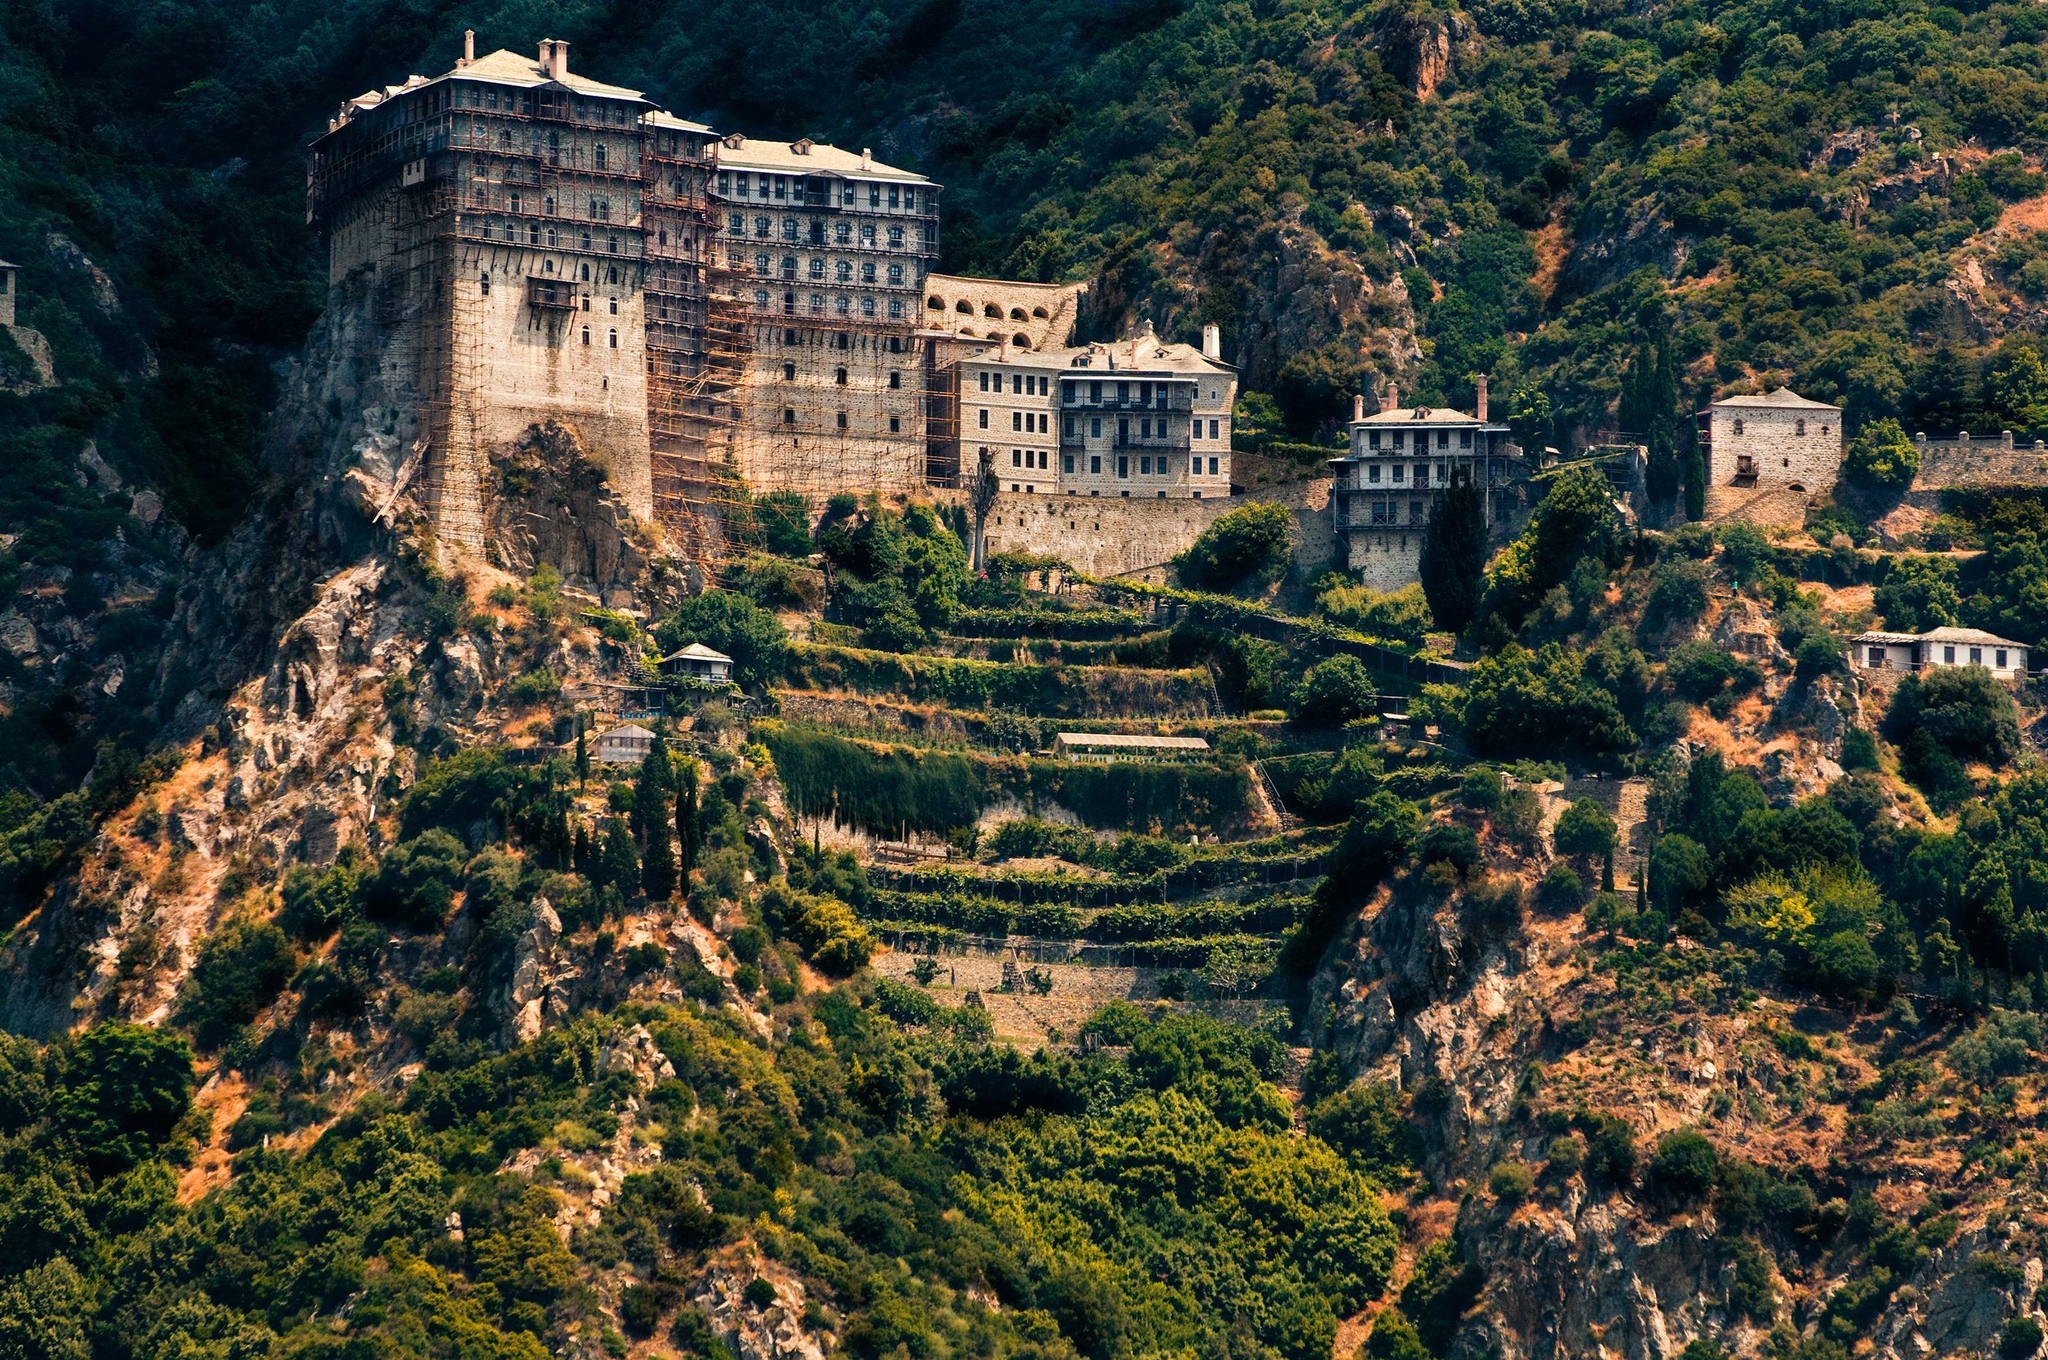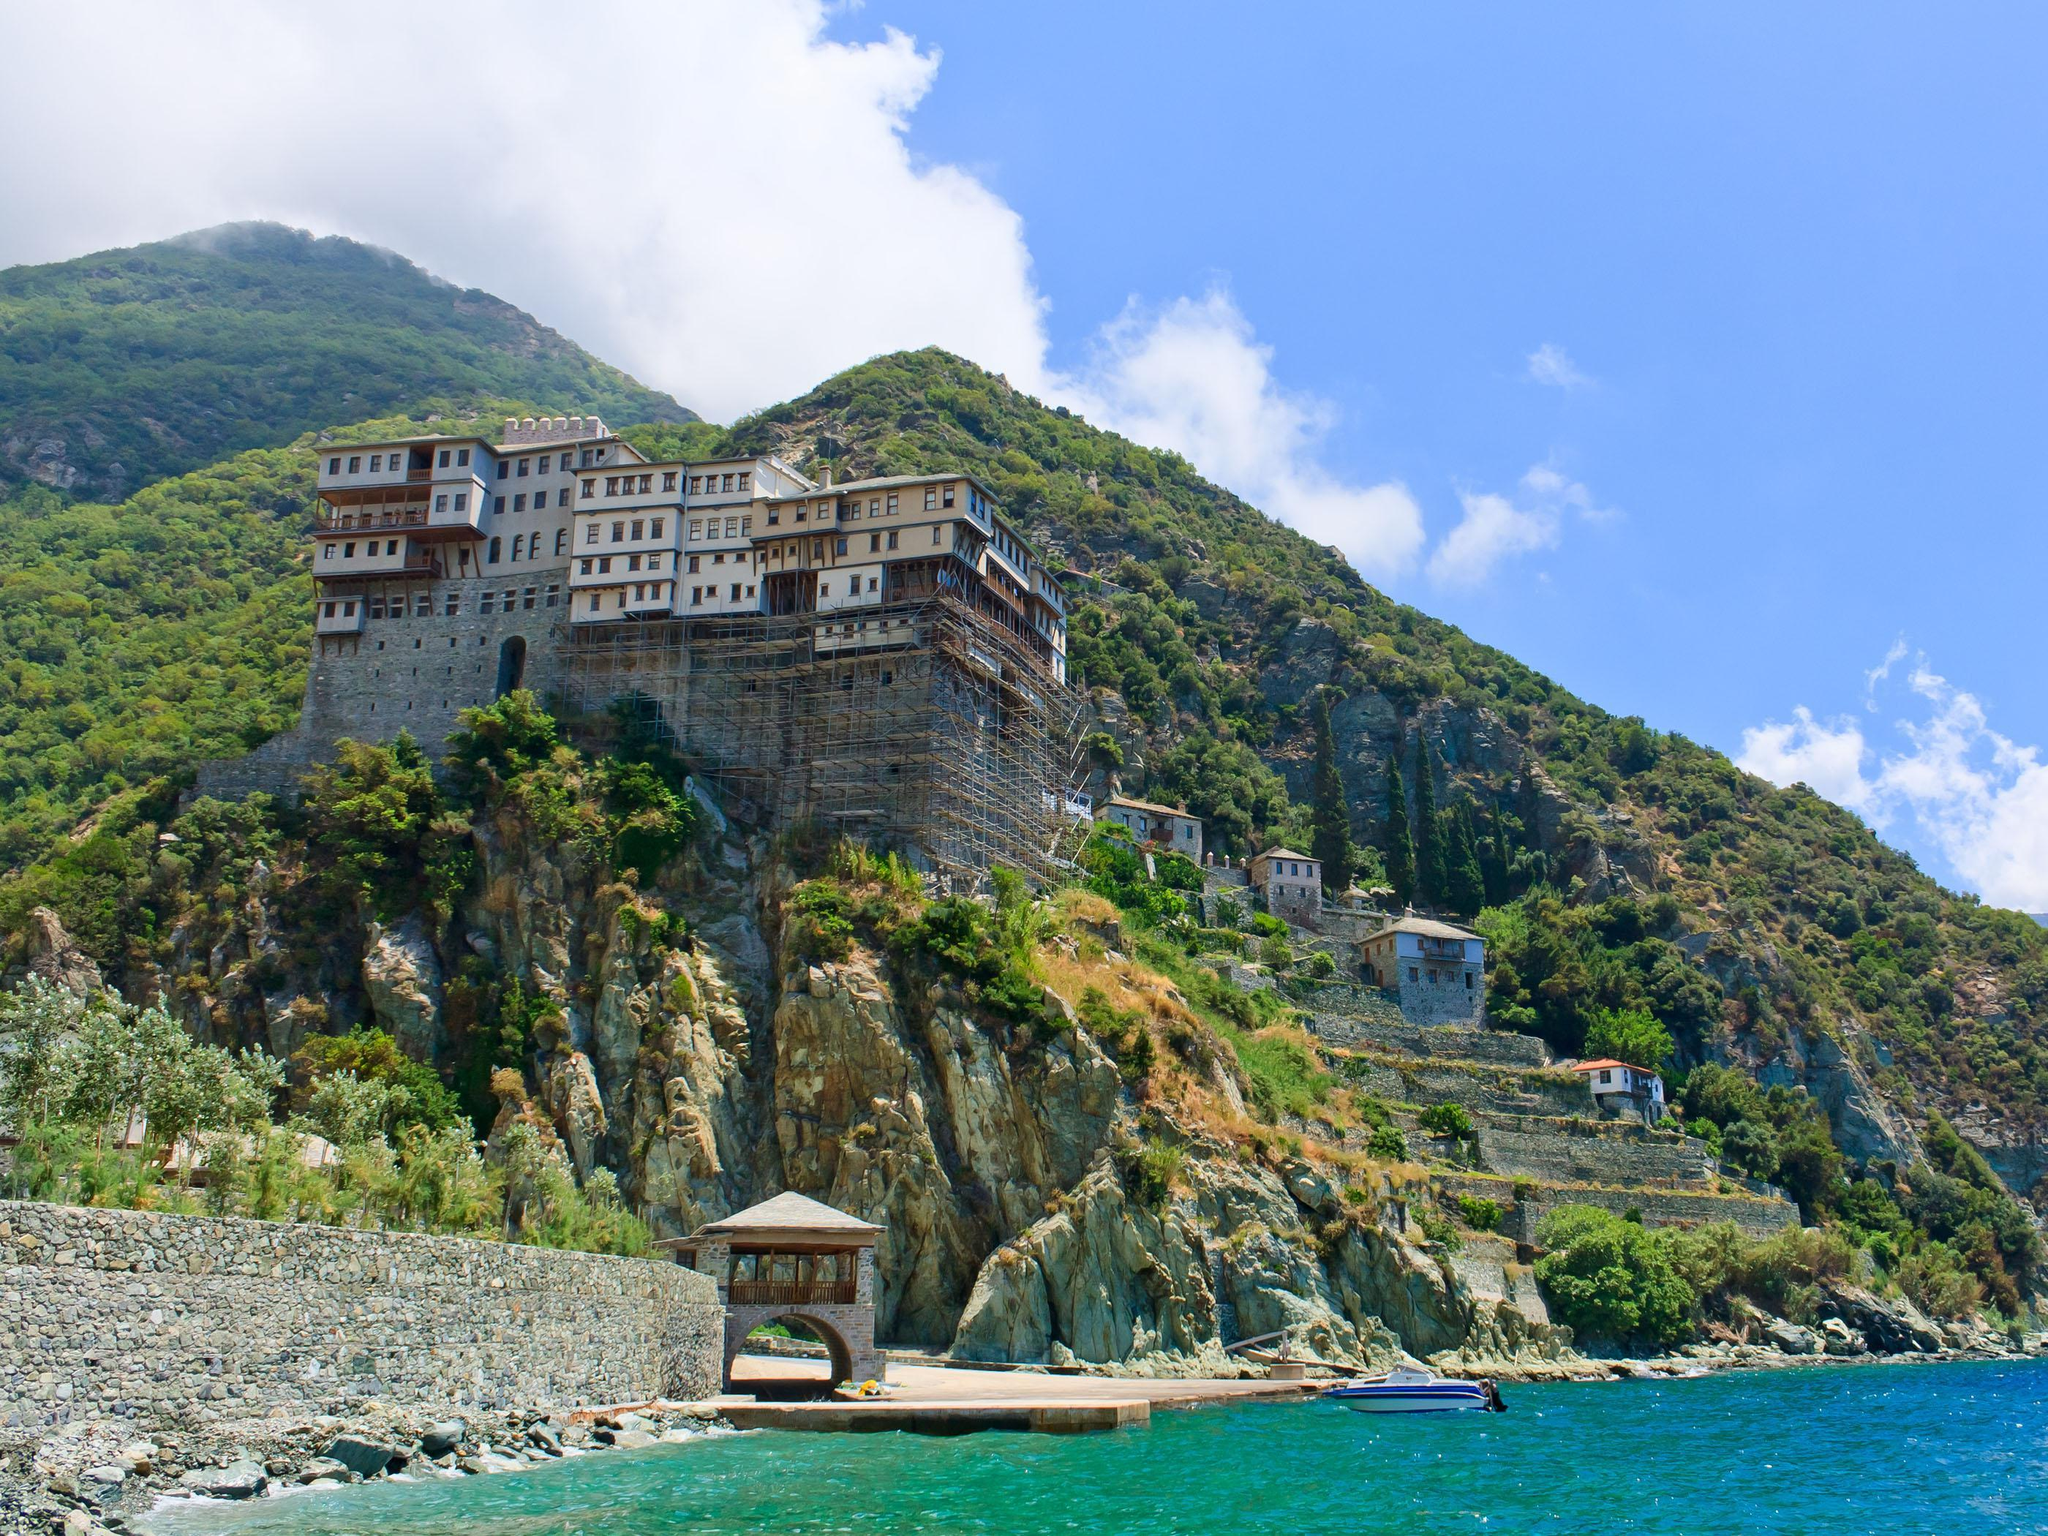The first image is the image on the left, the second image is the image on the right. Analyze the images presented: Is the assertion "There are hazy clouds in the image on the right." valid? Answer yes or no. Yes. 